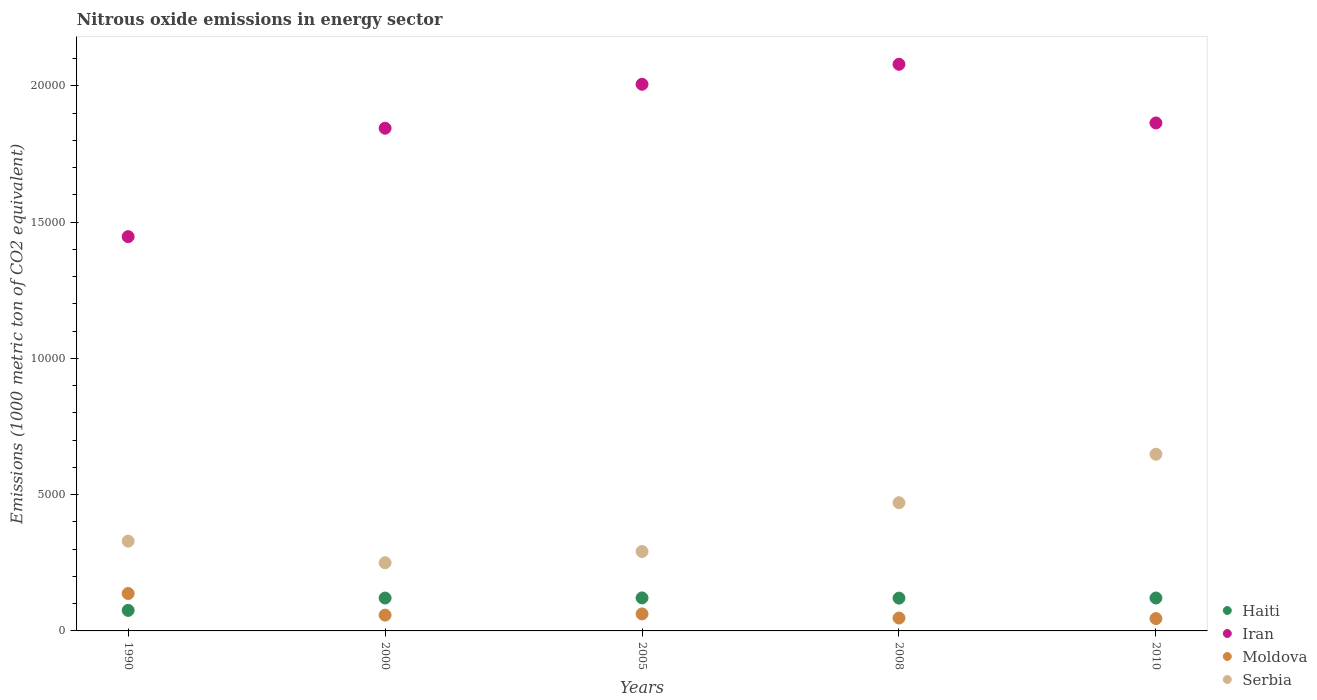How many different coloured dotlines are there?
Your response must be concise. 4. Is the number of dotlines equal to the number of legend labels?
Your answer should be very brief. Yes. What is the amount of nitrous oxide emitted in Haiti in 2010?
Offer a very short reply. 1207.7. Across all years, what is the maximum amount of nitrous oxide emitted in Serbia?
Give a very brief answer. 6482.7. Across all years, what is the minimum amount of nitrous oxide emitted in Iran?
Make the answer very short. 1.45e+04. What is the total amount of nitrous oxide emitted in Serbia in the graph?
Your response must be concise. 1.99e+04. What is the difference between the amount of nitrous oxide emitted in Serbia in 2005 and that in 2010?
Provide a short and direct response. -3568.9. What is the difference between the amount of nitrous oxide emitted in Haiti in 2000 and the amount of nitrous oxide emitted in Serbia in 2008?
Give a very brief answer. -3497.3. What is the average amount of nitrous oxide emitted in Moldova per year?
Provide a succinct answer. 700.52. In the year 2010, what is the difference between the amount of nitrous oxide emitted in Haiti and amount of nitrous oxide emitted in Iran?
Provide a short and direct response. -1.74e+04. What is the ratio of the amount of nitrous oxide emitted in Haiti in 1990 to that in 2008?
Offer a very short reply. 0.63. What is the difference between the highest and the second highest amount of nitrous oxide emitted in Moldova?
Offer a terse response. 749.2. What is the difference between the highest and the lowest amount of nitrous oxide emitted in Haiti?
Keep it short and to the point. 457.6. In how many years, is the amount of nitrous oxide emitted in Haiti greater than the average amount of nitrous oxide emitted in Haiti taken over all years?
Ensure brevity in your answer.  4. Is the sum of the amount of nitrous oxide emitted in Haiti in 2005 and 2010 greater than the maximum amount of nitrous oxide emitted in Iran across all years?
Make the answer very short. No. Is it the case that in every year, the sum of the amount of nitrous oxide emitted in Moldova and amount of nitrous oxide emitted in Haiti  is greater than the sum of amount of nitrous oxide emitted in Serbia and amount of nitrous oxide emitted in Iran?
Provide a succinct answer. No. Is the amount of nitrous oxide emitted in Haiti strictly less than the amount of nitrous oxide emitted in Iran over the years?
Provide a short and direct response. Yes. How many dotlines are there?
Offer a very short reply. 4. Does the graph contain grids?
Offer a very short reply. No. Where does the legend appear in the graph?
Your answer should be very brief. Bottom right. What is the title of the graph?
Your response must be concise. Nitrous oxide emissions in energy sector. Does "Sao Tome and Principe" appear as one of the legend labels in the graph?
Give a very brief answer. No. What is the label or title of the Y-axis?
Ensure brevity in your answer.  Emissions (1000 metric ton of CO2 equivalent). What is the Emissions (1000 metric ton of CO2 equivalent) in Haiti in 1990?
Give a very brief answer. 753.5. What is the Emissions (1000 metric ton of CO2 equivalent) in Iran in 1990?
Make the answer very short. 1.45e+04. What is the Emissions (1000 metric ton of CO2 equivalent) of Moldova in 1990?
Offer a very short reply. 1373.3. What is the Emissions (1000 metric ton of CO2 equivalent) of Serbia in 1990?
Your answer should be compact. 3293.8. What is the Emissions (1000 metric ton of CO2 equivalent) in Haiti in 2000?
Provide a short and direct response. 1206.3. What is the Emissions (1000 metric ton of CO2 equivalent) in Iran in 2000?
Provide a succinct answer. 1.84e+04. What is the Emissions (1000 metric ton of CO2 equivalent) in Moldova in 2000?
Your answer should be compact. 579.9. What is the Emissions (1000 metric ton of CO2 equivalent) in Serbia in 2000?
Provide a short and direct response. 2501.4. What is the Emissions (1000 metric ton of CO2 equivalent) of Haiti in 2005?
Offer a terse response. 1211.1. What is the Emissions (1000 metric ton of CO2 equivalent) in Iran in 2005?
Your response must be concise. 2.01e+04. What is the Emissions (1000 metric ton of CO2 equivalent) of Moldova in 2005?
Offer a terse response. 624.1. What is the Emissions (1000 metric ton of CO2 equivalent) of Serbia in 2005?
Offer a very short reply. 2913.8. What is the Emissions (1000 metric ton of CO2 equivalent) of Haiti in 2008?
Provide a short and direct response. 1203.2. What is the Emissions (1000 metric ton of CO2 equivalent) of Iran in 2008?
Give a very brief answer. 2.08e+04. What is the Emissions (1000 metric ton of CO2 equivalent) in Moldova in 2008?
Your answer should be compact. 472.4. What is the Emissions (1000 metric ton of CO2 equivalent) of Serbia in 2008?
Provide a succinct answer. 4703.6. What is the Emissions (1000 metric ton of CO2 equivalent) in Haiti in 2010?
Keep it short and to the point. 1207.7. What is the Emissions (1000 metric ton of CO2 equivalent) in Iran in 2010?
Make the answer very short. 1.86e+04. What is the Emissions (1000 metric ton of CO2 equivalent) in Moldova in 2010?
Offer a terse response. 452.9. What is the Emissions (1000 metric ton of CO2 equivalent) of Serbia in 2010?
Your answer should be very brief. 6482.7. Across all years, what is the maximum Emissions (1000 metric ton of CO2 equivalent) of Haiti?
Offer a very short reply. 1211.1. Across all years, what is the maximum Emissions (1000 metric ton of CO2 equivalent) in Iran?
Provide a short and direct response. 2.08e+04. Across all years, what is the maximum Emissions (1000 metric ton of CO2 equivalent) of Moldova?
Your answer should be very brief. 1373.3. Across all years, what is the maximum Emissions (1000 metric ton of CO2 equivalent) of Serbia?
Keep it short and to the point. 6482.7. Across all years, what is the minimum Emissions (1000 metric ton of CO2 equivalent) of Haiti?
Your answer should be compact. 753.5. Across all years, what is the minimum Emissions (1000 metric ton of CO2 equivalent) of Iran?
Ensure brevity in your answer.  1.45e+04. Across all years, what is the minimum Emissions (1000 metric ton of CO2 equivalent) of Moldova?
Make the answer very short. 452.9. Across all years, what is the minimum Emissions (1000 metric ton of CO2 equivalent) of Serbia?
Ensure brevity in your answer.  2501.4. What is the total Emissions (1000 metric ton of CO2 equivalent) of Haiti in the graph?
Offer a very short reply. 5581.8. What is the total Emissions (1000 metric ton of CO2 equivalent) of Iran in the graph?
Ensure brevity in your answer.  9.24e+04. What is the total Emissions (1000 metric ton of CO2 equivalent) of Moldova in the graph?
Provide a short and direct response. 3502.6. What is the total Emissions (1000 metric ton of CO2 equivalent) of Serbia in the graph?
Offer a very short reply. 1.99e+04. What is the difference between the Emissions (1000 metric ton of CO2 equivalent) of Haiti in 1990 and that in 2000?
Your answer should be compact. -452.8. What is the difference between the Emissions (1000 metric ton of CO2 equivalent) in Iran in 1990 and that in 2000?
Keep it short and to the point. -3977.6. What is the difference between the Emissions (1000 metric ton of CO2 equivalent) of Moldova in 1990 and that in 2000?
Your answer should be compact. 793.4. What is the difference between the Emissions (1000 metric ton of CO2 equivalent) in Serbia in 1990 and that in 2000?
Your response must be concise. 792.4. What is the difference between the Emissions (1000 metric ton of CO2 equivalent) of Haiti in 1990 and that in 2005?
Make the answer very short. -457.6. What is the difference between the Emissions (1000 metric ton of CO2 equivalent) in Iran in 1990 and that in 2005?
Keep it short and to the point. -5590.3. What is the difference between the Emissions (1000 metric ton of CO2 equivalent) of Moldova in 1990 and that in 2005?
Your response must be concise. 749.2. What is the difference between the Emissions (1000 metric ton of CO2 equivalent) of Serbia in 1990 and that in 2005?
Your answer should be very brief. 380. What is the difference between the Emissions (1000 metric ton of CO2 equivalent) in Haiti in 1990 and that in 2008?
Provide a short and direct response. -449.7. What is the difference between the Emissions (1000 metric ton of CO2 equivalent) in Iran in 1990 and that in 2008?
Provide a short and direct response. -6323.6. What is the difference between the Emissions (1000 metric ton of CO2 equivalent) in Moldova in 1990 and that in 2008?
Offer a terse response. 900.9. What is the difference between the Emissions (1000 metric ton of CO2 equivalent) in Serbia in 1990 and that in 2008?
Your answer should be very brief. -1409.8. What is the difference between the Emissions (1000 metric ton of CO2 equivalent) of Haiti in 1990 and that in 2010?
Keep it short and to the point. -454.2. What is the difference between the Emissions (1000 metric ton of CO2 equivalent) in Iran in 1990 and that in 2010?
Give a very brief answer. -4171.6. What is the difference between the Emissions (1000 metric ton of CO2 equivalent) of Moldova in 1990 and that in 2010?
Give a very brief answer. 920.4. What is the difference between the Emissions (1000 metric ton of CO2 equivalent) of Serbia in 1990 and that in 2010?
Offer a terse response. -3188.9. What is the difference between the Emissions (1000 metric ton of CO2 equivalent) in Haiti in 2000 and that in 2005?
Your response must be concise. -4.8. What is the difference between the Emissions (1000 metric ton of CO2 equivalent) in Iran in 2000 and that in 2005?
Your answer should be compact. -1612.7. What is the difference between the Emissions (1000 metric ton of CO2 equivalent) in Moldova in 2000 and that in 2005?
Ensure brevity in your answer.  -44.2. What is the difference between the Emissions (1000 metric ton of CO2 equivalent) of Serbia in 2000 and that in 2005?
Make the answer very short. -412.4. What is the difference between the Emissions (1000 metric ton of CO2 equivalent) of Haiti in 2000 and that in 2008?
Ensure brevity in your answer.  3.1. What is the difference between the Emissions (1000 metric ton of CO2 equivalent) of Iran in 2000 and that in 2008?
Provide a short and direct response. -2346. What is the difference between the Emissions (1000 metric ton of CO2 equivalent) of Moldova in 2000 and that in 2008?
Your answer should be compact. 107.5. What is the difference between the Emissions (1000 metric ton of CO2 equivalent) of Serbia in 2000 and that in 2008?
Provide a short and direct response. -2202.2. What is the difference between the Emissions (1000 metric ton of CO2 equivalent) in Haiti in 2000 and that in 2010?
Your answer should be very brief. -1.4. What is the difference between the Emissions (1000 metric ton of CO2 equivalent) in Iran in 2000 and that in 2010?
Make the answer very short. -194. What is the difference between the Emissions (1000 metric ton of CO2 equivalent) in Moldova in 2000 and that in 2010?
Keep it short and to the point. 127. What is the difference between the Emissions (1000 metric ton of CO2 equivalent) in Serbia in 2000 and that in 2010?
Ensure brevity in your answer.  -3981.3. What is the difference between the Emissions (1000 metric ton of CO2 equivalent) in Iran in 2005 and that in 2008?
Your answer should be very brief. -733.3. What is the difference between the Emissions (1000 metric ton of CO2 equivalent) in Moldova in 2005 and that in 2008?
Your answer should be compact. 151.7. What is the difference between the Emissions (1000 metric ton of CO2 equivalent) in Serbia in 2005 and that in 2008?
Make the answer very short. -1789.8. What is the difference between the Emissions (1000 metric ton of CO2 equivalent) of Iran in 2005 and that in 2010?
Offer a very short reply. 1418.7. What is the difference between the Emissions (1000 metric ton of CO2 equivalent) in Moldova in 2005 and that in 2010?
Make the answer very short. 171.2. What is the difference between the Emissions (1000 metric ton of CO2 equivalent) in Serbia in 2005 and that in 2010?
Your answer should be very brief. -3568.9. What is the difference between the Emissions (1000 metric ton of CO2 equivalent) in Haiti in 2008 and that in 2010?
Provide a short and direct response. -4.5. What is the difference between the Emissions (1000 metric ton of CO2 equivalent) in Iran in 2008 and that in 2010?
Offer a terse response. 2152. What is the difference between the Emissions (1000 metric ton of CO2 equivalent) of Moldova in 2008 and that in 2010?
Offer a very short reply. 19.5. What is the difference between the Emissions (1000 metric ton of CO2 equivalent) in Serbia in 2008 and that in 2010?
Give a very brief answer. -1779.1. What is the difference between the Emissions (1000 metric ton of CO2 equivalent) in Haiti in 1990 and the Emissions (1000 metric ton of CO2 equivalent) in Iran in 2000?
Make the answer very short. -1.77e+04. What is the difference between the Emissions (1000 metric ton of CO2 equivalent) in Haiti in 1990 and the Emissions (1000 metric ton of CO2 equivalent) in Moldova in 2000?
Provide a short and direct response. 173.6. What is the difference between the Emissions (1000 metric ton of CO2 equivalent) in Haiti in 1990 and the Emissions (1000 metric ton of CO2 equivalent) in Serbia in 2000?
Your answer should be compact. -1747.9. What is the difference between the Emissions (1000 metric ton of CO2 equivalent) of Iran in 1990 and the Emissions (1000 metric ton of CO2 equivalent) of Moldova in 2000?
Provide a short and direct response. 1.39e+04. What is the difference between the Emissions (1000 metric ton of CO2 equivalent) of Iran in 1990 and the Emissions (1000 metric ton of CO2 equivalent) of Serbia in 2000?
Provide a succinct answer. 1.20e+04. What is the difference between the Emissions (1000 metric ton of CO2 equivalent) of Moldova in 1990 and the Emissions (1000 metric ton of CO2 equivalent) of Serbia in 2000?
Provide a succinct answer. -1128.1. What is the difference between the Emissions (1000 metric ton of CO2 equivalent) of Haiti in 1990 and the Emissions (1000 metric ton of CO2 equivalent) of Iran in 2005?
Your answer should be compact. -1.93e+04. What is the difference between the Emissions (1000 metric ton of CO2 equivalent) in Haiti in 1990 and the Emissions (1000 metric ton of CO2 equivalent) in Moldova in 2005?
Your response must be concise. 129.4. What is the difference between the Emissions (1000 metric ton of CO2 equivalent) in Haiti in 1990 and the Emissions (1000 metric ton of CO2 equivalent) in Serbia in 2005?
Your answer should be compact. -2160.3. What is the difference between the Emissions (1000 metric ton of CO2 equivalent) in Iran in 1990 and the Emissions (1000 metric ton of CO2 equivalent) in Moldova in 2005?
Ensure brevity in your answer.  1.38e+04. What is the difference between the Emissions (1000 metric ton of CO2 equivalent) in Iran in 1990 and the Emissions (1000 metric ton of CO2 equivalent) in Serbia in 2005?
Your answer should be very brief. 1.16e+04. What is the difference between the Emissions (1000 metric ton of CO2 equivalent) in Moldova in 1990 and the Emissions (1000 metric ton of CO2 equivalent) in Serbia in 2005?
Make the answer very short. -1540.5. What is the difference between the Emissions (1000 metric ton of CO2 equivalent) in Haiti in 1990 and the Emissions (1000 metric ton of CO2 equivalent) in Iran in 2008?
Your answer should be compact. -2.00e+04. What is the difference between the Emissions (1000 metric ton of CO2 equivalent) of Haiti in 1990 and the Emissions (1000 metric ton of CO2 equivalent) of Moldova in 2008?
Keep it short and to the point. 281.1. What is the difference between the Emissions (1000 metric ton of CO2 equivalent) of Haiti in 1990 and the Emissions (1000 metric ton of CO2 equivalent) of Serbia in 2008?
Provide a succinct answer. -3950.1. What is the difference between the Emissions (1000 metric ton of CO2 equivalent) of Iran in 1990 and the Emissions (1000 metric ton of CO2 equivalent) of Moldova in 2008?
Your response must be concise. 1.40e+04. What is the difference between the Emissions (1000 metric ton of CO2 equivalent) of Iran in 1990 and the Emissions (1000 metric ton of CO2 equivalent) of Serbia in 2008?
Keep it short and to the point. 9762.1. What is the difference between the Emissions (1000 metric ton of CO2 equivalent) of Moldova in 1990 and the Emissions (1000 metric ton of CO2 equivalent) of Serbia in 2008?
Provide a short and direct response. -3330.3. What is the difference between the Emissions (1000 metric ton of CO2 equivalent) in Haiti in 1990 and the Emissions (1000 metric ton of CO2 equivalent) in Iran in 2010?
Provide a short and direct response. -1.79e+04. What is the difference between the Emissions (1000 metric ton of CO2 equivalent) of Haiti in 1990 and the Emissions (1000 metric ton of CO2 equivalent) of Moldova in 2010?
Offer a terse response. 300.6. What is the difference between the Emissions (1000 metric ton of CO2 equivalent) of Haiti in 1990 and the Emissions (1000 metric ton of CO2 equivalent) of Serbia in 2010?
Offer a very short reply. -5729.2. What is the difference between the Emissions (1000 metric ton of CO2 equivalent) in Iran in 1990 and the Emissions (1000 metric ton of CO2 equivalent) in Moldova in 2010?
Offer a very short reply. 1.40e+04. What is the difference between the Emissions (1000 metric ton of CO2 equivalent) of Iran in 1990 and the Emissions (1000 metric ton of CO2 equivalent) of Serbia in 2010?
Keep it short and to the point. 7983. What is the difference between the Emissions (1000 metric ton of CO2 equivalent) of Moldova in 1990 and the Emissions (1000 metric ton of CO2 equivalent) of Serbia in 2010?
Ensure brevity in your answer.  -5109.4. What is the difference between the Emissions (1000 metric ton of CO2 equivalent) in Haiti in 2000 and the Emissions (1000 metric ton of CO2 equivalent) in Iran in 2005?
Your response must be concise. -1.88e+04. What is the difference between the Emissions (1000 metric ton of CO2 equivalent) in Haiti in 2000 and the Emissions (1000 metric ton of CO2 equivalent) in Moldova in 2005?
Your response must be concise. 582.2. What is the difference between the Emissions (1000 metric ton of CO2 equivalent) in Haiti in 2000 and the Emissions (1000 metric ton of CO2 equivalent) in Serbia in 2005?
Ensure brevity in your answer.  -1707.5. What is the difference between the Emissions (1000 metric ton of CO2 equivalent) in Iran in 2000 and the Emissions (1000 metric ton of CO2 equivalent) in Moldova in 2005?
Your response must be concise. 1.78e+04. What is the difference between the Emissions (1000 metric ton of CO2 equivalent) of Iran in 2000 and the Emissions (1000 metric ton of CO2 equivalent) of Serbia in 2005?
Your response must be concise. 1.55e+04. What is the difference between the Emissions (1000 metric ton of CO2 equivalent) of Moldova in 2000 and the Emissions (1000 metric ton of CO2 equivalent) of Serbia in 2005?
Your answer should be compact. -2333.9. What is the difference between the Emissions (1000 metric ton of CO2 equivalent) in Haiti in 2000 and the Emissions (1000 metric ton of CO2 equivalent) in Iran in 2008?
Give a very brief answer. -1.96e+04. What is the difference between the Emissions (1000 metric ton of CO2 equivalent) in Haiti in 2000 and the Emissions (1000 metric ton of CO2 equivalent) in Moldova in 2008?
Your response must be concise. 733.9. What is the difference between the Emissions (1000 metric ton of CO2 equivalent) in Haiti in 2000 and the Emissions (1000 metric ton of CO2 equivalent) in Serbia in 2008?
Your answer should be compact. -3497.3. What is the difference between the Emissions (1000 metric ton of CO2 equivalent) in Iran in 2000 and the Emissions (1000 metric ton of CO2 equivalent) in Moldova in 2008?
Your answer should be very brief. 1.80e+04. What is the difference between the Emissions (1000 metric ton of CO2 equivalent) of Iran in 2000 and the Emissions (1000 metric ton of CO2 equivalent) of Serbia in 2008?
Your response must be concise. 1.37e+04. What is the difference between the Emissions (1000 metric ton of CO2 equivalent) of Moldova in 2000 and the Emissions (1000 metric ton of CO2 equivalent) of Serbia in 2008?
Provide a short and direct response. -4123.7. What is the difference between the Emissions (1000 metric ton of CO2 equivalent) of Haiti in 2000 and the Emissions (1000 metric ton of CO2 equivalent) of Iran in 2010?
Make the answer very short. -1.74e+04. What is the difference between the Emissions (1000 metric ton of CO2 equivalent) in Haiti in 2000 and the Emissions (1000 metric ton of CO2 equivalent) in Moldova in 2010?
Make the answer very short. 753.4. What is the difference between the Emissions (1000 metric ton of CO2 equivalent) of Haiti in 2000 and the Emissions (1000 metric ton of CO2 equivalent) of Serbia in 2010?
Make the answer very short. -5276.4. What is the difference between the Emissions (1000 metric ton of CO2 equivalent) in Iran in 2000 and the Emissions (1000 metric ton of CO2 equivalent) in Moldova in 2010?
Your answer should be very brief. 1.80e+04. What is the difference between the Emissions (1000 metric ton of CO2 equivalent) in Iran in 2000 and the Emissions (1000 metric ton of CO2 equivalent) in Serbia in 2010?
Your answer should be very brief. 1.20e+04. What is the difference between the Emissions (1000 metric ton of CO2 equivalent) of Moldova in 2000 and the Emissions (1000 metric ton of CO2 equivalent) of Serbia in 2010?
Offer a terse response. -5902.8. What is the difference between the Emissions (1000 metric ton of CO2 equivalent) in Haiti in 2005 and the Emissions (1000 metric ton of CO2 equivalent) in Iran in 2008?
Ensure brevity in your answer.  -1.96e+04. What is the difference between the Emissions (1000 metric ton of CO2 equivalent) in Haiti in 2005 and the Emissions (1000 metric ton of CO2 equivalent) in Moldova in 2008?
Your answer should be very brief. 738.7. What is the difference between the Emissions (1000 metric ton of CO2 equivalent) of Haiti in 2005 and the Emissions (1000 metric ton of CO2 equivalent) of Serbia in 2008?
Your answer should be compact. -3492.5. What is the difference between the Emissions (1000 metric ton of CO2 equivalent) of Iran in 2005 and the Emissions (1000 metric ton of CO2 equivalent) of Moldova in 2008?
Make the answer very short. 1.96e+04. What is the difference between the Emissions (1000 metric ton of CO2 equivalent) in Iran in 2005 and the Emissions (1000 metric ton of CO2 equivalent) in Serbia in 2008?
Give a very brief answer. 1.54e+04. What is the difference between the Emissions (1000 metric ton of CO2 equivalent) of Moldova in 2005 and the Emissions (1000 metric ton of CO2 equivalent) of Serbia in 2008?
Give a very brief answer. -4079.5. What is the difference between the Emissions (1000 metric ton of CO2 equivalent) in Haiti in 2005 and the Emissions (1000 metric ton of CO2 equivalent) in Iran in 2010?
Provide a succinct answer. -1.74e+04. What is the difference between the Emissions (1000 metric ton of CO2 equivalent) of Haiti in 2005 and the Emissions (1000 metric ton of CO2 equivalent) of Moldova in 2010?
Offer a terse response. 758.2. What is the difference between the Emissions (1000 metric ton of CO2 equivalent) of Haiti in 2005 and the Emissions (1000 metric ton of CO2 equivalent) of Serbia in 2010?
Keep it short and to the point. -5271.6. What is the difference between the Emissions (1000 metric ton of CO2 equivalent) of Iran in 2005 and the Emissions (1000 metric ton of CO2 equivalent) of Moldova in 2010?
Provide a short and direct response. 1.96e+04. What is the difference between the Emissions (1000 metric ton of CO2 equivalent) in Iran in 2005 and the Emissions (1000 metric ton of CO2 equivalent) in Serbia in 2010?
Provide a short and direct response. 1.36e+04. What is the difference between the Emissions (1000 metric ton of CO2 equivalent) of Moldova in 2005 and the Emissions (1000 metric ton of CO2 equivalent) of Serbia in 2010?
Your answer should be very brief. -5858.6. What is the difference between the Emissions (1000 metric ton of CO2 equivalent) of Haiti in 2008 and the Emissions (1000 metric ton of CO2 equivalent) of Iran in 2010?
Ensure brevity in your answer.  -1.74e+04. What is the difference between the Emissions (1000 metric ton of CO2 equivalent) of Haiti in 2008 and the Emissions (1000 metric ton of CO2 equivalent) of Moldova in 2010?
Provide a succinct answer. 750.3. What is the difference between the Emissions (1000 metric ton of CO2 equivalent) of Haiti in 2008 and the Emissions (1000 metric ton of CO2 equivalent) of Serbia in 2010?
Keep it short and to the point. -5279.5. What is the difference between the Emissions (1000 metric ton of CO2 equivalent) in Iran in 2008 and the Emissions (1000 metric ton of CO2 equivalent) in Moldova in 2010?
Provide a short and direct response. 2.03e+04. What is the difference between the Emissions (1000 metric ton of CO2 equivalent) in Iran in 2008 and the Emissions (1000 metric ton of CO2 equivalent) in Serbia in 2010?
Offer a terse response. 1.43e+04. What is the difference between the Emissions (1000 metric ton of CO2 equivalent) of Moldova in 2008 and the Emissions (1000 metric ton of CO2 equivalent) of Serbia in 2010?
Provide a short and direct response. -6010.3. What is the average Emissions (1000 metric ton of CO2 equivalent) in Haiti per year?
Offer a terse response. 1116.36. What is the average Emissions (1000 metric ton of CO2 equivalent) in Iran per year?
Offer a terse response. 1.85e+04. What is the average Emissions (1000 metric ton of CO2 equivalent) in Moldova per year?
Provide a succinct answer. 700.52. What is the average Emissions (1000 metric ton of CO2 equivalent) in Serbia per year?
Make the answer very short. 3979.06. In the year 1990, what is the difference between the Emissions (1000 metric ton of CO2 equivalent) of Haiti and Emissions (1000 metric ton of CO2 equivalent) of Iran?
Keep it short and to the point. -1.37e+04. In the year 1990, what is the difference between the Emissions (1000 metric ton of CO2 equivalent) of Haiti and Emissions (1000 metric ton of CO2 equivalent) of Moldova?
Make the answer very short. -619.8. In the year 1990, what is the difference between the Emissions (1000 metric ton of CO2 equivalent) of Haiti and Emissions (1000 metric ton of CO2 equivalent) of Serbia?
Your answer should be very brief. -2540.3. In the year 1990, what is the difference between the Emissions (1000 metric ton of CO2 equivalent) in Iran and Emissions (1000 metric ton of CO2 equivalent) in Moldova?
Make the answer very short. 1.31e+04. In the year 1990, what is the difference between the Emissions (1000 metric ton of CO2 equivalent) of Iran and Emissions (1000 metric ton of CO2 equivalent) of Serbia?
Provide a succinct answer. 1.12e+04. In the year 1990, what is the difference between the Emissions (1000 metric ton of CO2 equivalent) in Moldova and Emissions (1000 metric ton of CO2 equivalent) in Serbia?
Give a very brief answer. -1920.5. In the year 2000, what is the difference between the Emissions (1000 metric ton of CO2 equivalent) of Haiti and Emissions (1000 metric ton of CO2 equivalent) of Iran?
Your response must be concise. -1.72e+04. In the year 2000, what is the difference between the Emissions (1000 metric ton of CO2 equivalent) of Haiti and Emissions (1000 metric ton of CO2 equivalent) of Moldova?
Your answer should be very brief. 626.4. In the year 2000, what is the difference between the Emissions (1000 metric ton of CO2 equivalent) of Haiti and Emissions (1000 metric ton of CO2 equivalent) of Serbia?
Ensure brevity in your answer.  -1295.1. In the year 2000, what is the difference between the Emissions (1000 metric ton of CO2 equivalent) in Iran and Emissions (1000 metric ton of CO2 equivalent) in Moldova?
Make the answer very short. 1.79e+04. In the year 2000, what is the difference between the Emissions (1000 metric ton of CO2 equivalent) in Iran and Emissions (1000 metric ton of CO2 equivalent) in Serbia?
Ensure brevity in your answer.  1.59e+04. In the year 2000, what is the difference between the Emissions (1000 metric ton of CO2 equivalent) in Moldova and Emissions (1000 metric ton of CO2 equivalent) in Serbia?
Offer a terse response. -1921.5. In the year 2005, what is the difference between the Emissions (1000 metric ton of CO2 equivalent) of Haiti and Emissions (1000 metric ton of CO2 equivalent) of Iran?
Give a very brief answer. -1.88e+04. In the year 2005, what is the difference between the Emissions (1000 metric ton of CO2 equivalent) of Haiti and Emissions (1000 metric ton of CO2 equivalent) of Moldova?
Give a very brief answer. 587. In the year 2005, what is the difference between the Emissions (1000 metric ton of CO2 equivalent) of Haiti and Emissions (1000 metric ton of CO2 equivalent) of Serbia?
Make the answer very short. -1702.7. In the year 2005, what is the difference between the Emissions (1000 metric ton of CO2 equivalent) in Iran and Emissions (1000 metric ton of CO2 equivalent) in Moldova?
Your response must be concise. 1.94e+04. In the year 2005, what is the difference between the Emissions (1000 metric ton of CO2 equivalent) of Iran and Emissions (1000 metric ton of CO2 equivalent) of Serbia?
Provide a short and direct response. 1.71e+04. In the year 2005, what is the difference between the Emissions (1000 metric ton of CO2 equivalent) of Moldova and Emissions (1000 metric ton of CO2 equivalent) of Serbia?
Your response must be concise. -2289.7. In the year 2008, what is the difference between the Emissions (1000 metric ton of CO2 equivalent) of Haiti and Emissions (1000 metric ton of CO2 equivalent) of Iran?
Make the answer very short. -1.96e+04. In the year 2008, what is the difference between the Emissions (1000 metric ton of CO2 equivalent) of Haiti and Emissions (1000 metric ton of CO2 equivalent) of Moldova?
Ensure brevity in your answer.  730.8. In the year 2008, what is the difference between the Emissions (1000 metric ton of CO2 equivalent) of Haiti and Emissions (1000 metric ton of CO2 equivalent) of Serbia?
Ensure brevity in your answer.  -3500.4. In the year 2008, what is the difference between the Emissions (1000 metric ton of CO2 equivalent) in Iran and Emissions (1000 metric ton of CO2 equivalent) in Moldova?
Your answer should be very brief. 2.03e+04. In the year 2008, what is the difference between the Emissions (1000 metric ton of CO2 equivalent) of Iran and Emissions (1000 metric ton of CO2 equivalent) of Serbia?
Provide a short and direct response. 1.61e+04. In the year 2008, what is the difference between the Emissions (1000 metric ton of CO2 equivalent) in Moldova and Emissions (1000 metric ton of CO2 equivalent) in Serbia?
Make the answer very short. -4231.2. In the year 2010, what is the difference between the Emissions (1000 metric ton of CO2 equivalent) of Haiti and Emissions (1000 metric ton of CO2 equivalent) of Iran?
Provide a short and direct response. -1.74e+04. In the year 2010, what is the difference between the Emissions (1000 metric ton of CO2 equivalent) of Haiti and Emissions (1000 metric ton of CO2 equivalent) of Moldova?
Offer a very short reply. 754.8. In the year 2010, what is the difference between the Emissions (1000 metric ton of CO2 equivalent) in Haiti and Emissions (1000 metric ton of CO2 equivalent) in Serbia?
Offer a very short reply. -5275. In the year 2010, what is the difference between the Emissions (1000 metric ton of CO2 equivalent) of Iran and Emissions (1000 metric ton of CO2 equivalent) of Moldova?
Your response must be concise. 1.82e+04. In the year 2010, what is the difference between the Emissions (1000 metric ton of CO2 equivalent) of Iran and Emissions (1000 metric ton of CO2 equivalent) of Serbia?
Offer a very short reply. 1.22e+04. In the year 2010, what is the difference between the Emissions (1000 metric ton of CO2 equivalent) in Moldova and Emissions (1000 metric ton of CO2 equivalent) in Serbia?
Your response must be concise. -6029.8. What is the ratio of the Emissions (1000 metric ton of CO2 equivalent) in Haiti in 1990 to that in 2000?
Offer a terse response. 0.62. What is the ratio of the Emissions (1000 metric ton of CO2 equivalent) in Iran in 1990 to that in 2000?
Keep it short and to the point. 0.78. What is the ratio of the Emissions (1000 metric ton of CO2 equivalent) of Moldova in 1990 to that in 2000?
Provide a succinct answer. 2.37. What is the ratio of the Emissions (1000 metric ton of CO2 equivalent) of Serbia in 1990 to that in 2000?
Provide a short and direct response. 1.32. What is the ratio of the Emissions (1000 metric ton of CO2 equivalent) of Haiti in 1990 to that in 2005?
Give a very brief answer. 0.62. What is the ratio of the Emissions (1000 metric ton of CO2 equivalent) of Iran in 1990 to that in 2005?
Give a very brief answer. 0.72. What is the ratio of the Emissions (1000 metric ton of CO2 equivalent) in Moldova in 1990 to that in 2005?
Offer a very short reply. 2.2. What is the ratio of the Emissions (1000 metric ton of CO2 equivalent) of Serbia in 1990 to that in 2005?
Your answer should be compact. 1.13. What is the ratio of the Emissions (1000 metric ton of CO2 equivalent) of Haiti in 1990 to that in 2008?
Your answer should be compact. 0.63. What is the ratio of the Emissions (1000 metric ton of CO2 equivalent) of Iran in 1990 to that in 2008?
Your answer should be compact. 0.7. What is the ratio of the Emissions (1000 metric ton of CO2 equivalent) in Moldova in 1990 to that in 2008?
Give a very brief answer. 2.91. What is the ratio of the Emissions (1000 metric ton of CO2 equivalent) in Serbia in 1990 to that in 2008?
Make the answer very short. 0.7. What is the ratio of the Emissions (1000 metric ton of CO2 equivalent) in Haiti in 1990 to that in 2010?
Give a very brief answer. 0.62. What is the ratio of the Emissions (1000 metric ton of CO2 equivalent) of Iran in 1990 to that in 2010?
Your answer should be very brief. 0.78. What is the ratio of the Emissions (1000 metric ton of CO2 equivalent) in Moldova in 1990 to that in 2010?
Your answer should be compact. 3.03. What is the ratio of the Emissions (1000 metric ton of CO2 equivalent) in Serbia in 1990 to that in 2010?
Your answer should be compact. 0.51. What is the ratio of the Emissions (1000 metric ton of CO2 equivalent) in Iran in 2000 to that in 2005?
Make the answer very short. 0.92. What is the ratio of the Emissions (1000 metric ton of CO2 equivalent) of Moldova in 2000 to that in 2005?
Provide a succinct answer. 0.93. What is the ratio of the Emissions (1000 metric ton of CO2 equivalent) of Serbia in 2000 to that in 2005?
Give a very brief answer. 0.86. What is the ratio of the Emissions (1000 metric ton of CO2 equivalent) in Iran in 2000 to that in 2008?
Ensure brevity in your answer.  0.89. What is the ratio of the Emissions (1000 metric ton of CO2 equivalent) in Moldova in 2000 to that in 2008?
Offer a terse response. 1.23. What is the ratio of the Emissions (1000 metric ton of CO2 equivalent) in Serbia in 2000 to that in 2008?
Give a very brief answer. 0.53. What is the ratio of the Emissions (1000 metric ton of CO2 equivalent) in Haiti in 2000 to that in 2010?
Provide a succinct answer. 1. What is the ratio of the Emissions (1000 metric ton of CO2 equivalent) in Moldova in 2000 to that in 2010?
Offer a very short reply. 1.28. What is the ratio of the Emissions (1000 metric ton of CO2 equivalent) of Serbia in 2000 to that in 2010?
Give a very brief answer. 0.39. What is the ratio of the Emissions (1000 metric ton of CO2 equivalent) in Haiti in 2005 to that in 2008?
Your response must be concise. 1.01. What is the ratio of the Emissions (1000 metric ton of CO2 equivalent) of Iran in 2005 to that in 2008?
Your answer should be very brief. 0.96. What is the ratio of the Emissions (1000 metric ton of CO2 equivalent) in Moldova in 2005 to that in 2008?
Keep it short and to the point. 1.32. What is the ratio of the Emissions (1000 metric ton of CO2 equivalent) in Serbia in 2005 to that in 2008?
Give a very brief answer. 0.62. What is the ratio of the Emissions (1000 metric ton of CO2 equivalent) in Iran in 2005 to that in 2010?
Keep it short and to the point. 1.08. What is the ratio of the Emissions (1000 metric ton of CO2 equivalent) of Moldova in 2005 to that in 2010?
Offer a terse response. 1.38. What is the ratio of the Emissions (1000 metric ton of CO2 equivalent) of Serbia in 2005 to that in 2010?
Give a very brief answer. 0.45. What is the ratio of the Emissions (1000 metric ton of CO2 equivalent) of Haiti in 2008 to that in 2010?
Ensure brevity in your answer.  1. What is the ratio of the Emissions (1000 metric ton of CO2 equivalent) in Iran in 2008 to that in 2010?
Keep it short and to the point. 1.12. What is the ratio of the Emissions (1000 metric ton of CO2 equivalent) of Moldova in 2008 to that in 2010?
Your answer should be compact. 1.04. What is the ratio of the Emissions (1000 metric ton of CO2 equivalent) in Serbia in 2008 to that in 2010?
Offer a very short reply. 0.73. What is the difference between the highest and the second highest Emissions (1000 metric ton of CO2 equivalent) in Iran?
Keep it short and to the point. 733.3. What is the difference between the highest and the second highest Emissions (1000 metric ton of CO2 equivalent) of Moldova?
Make the answer very short. 749.2. What is the difference between the highest and the second highest Emissions (1000 metric ton of CO2 equivalent) of Serbia?
Ensure brevity in your answer.  1779.1. What is the difference between the highest and the lowest Emissions (1000 metric ton of CO2 equivalent) in Haiti?
Offer a terse response. 457.6. What is the difference between the highest and the lowest Emissions (1000 metric ton of CO2 equivalent) of Iran?
Offer a very short reply. 6323.6. What is the difference between the highest and the lowest Emissions (1000 metric ton of CO2 equivalent) in Moldova?
Provide a short and direct response. 920.4. What is the difference between the highest and the lowest Emissions (1000 metric ton of CO2 equivalent) of Serbia?
Make the answer very short. 3981.3. 